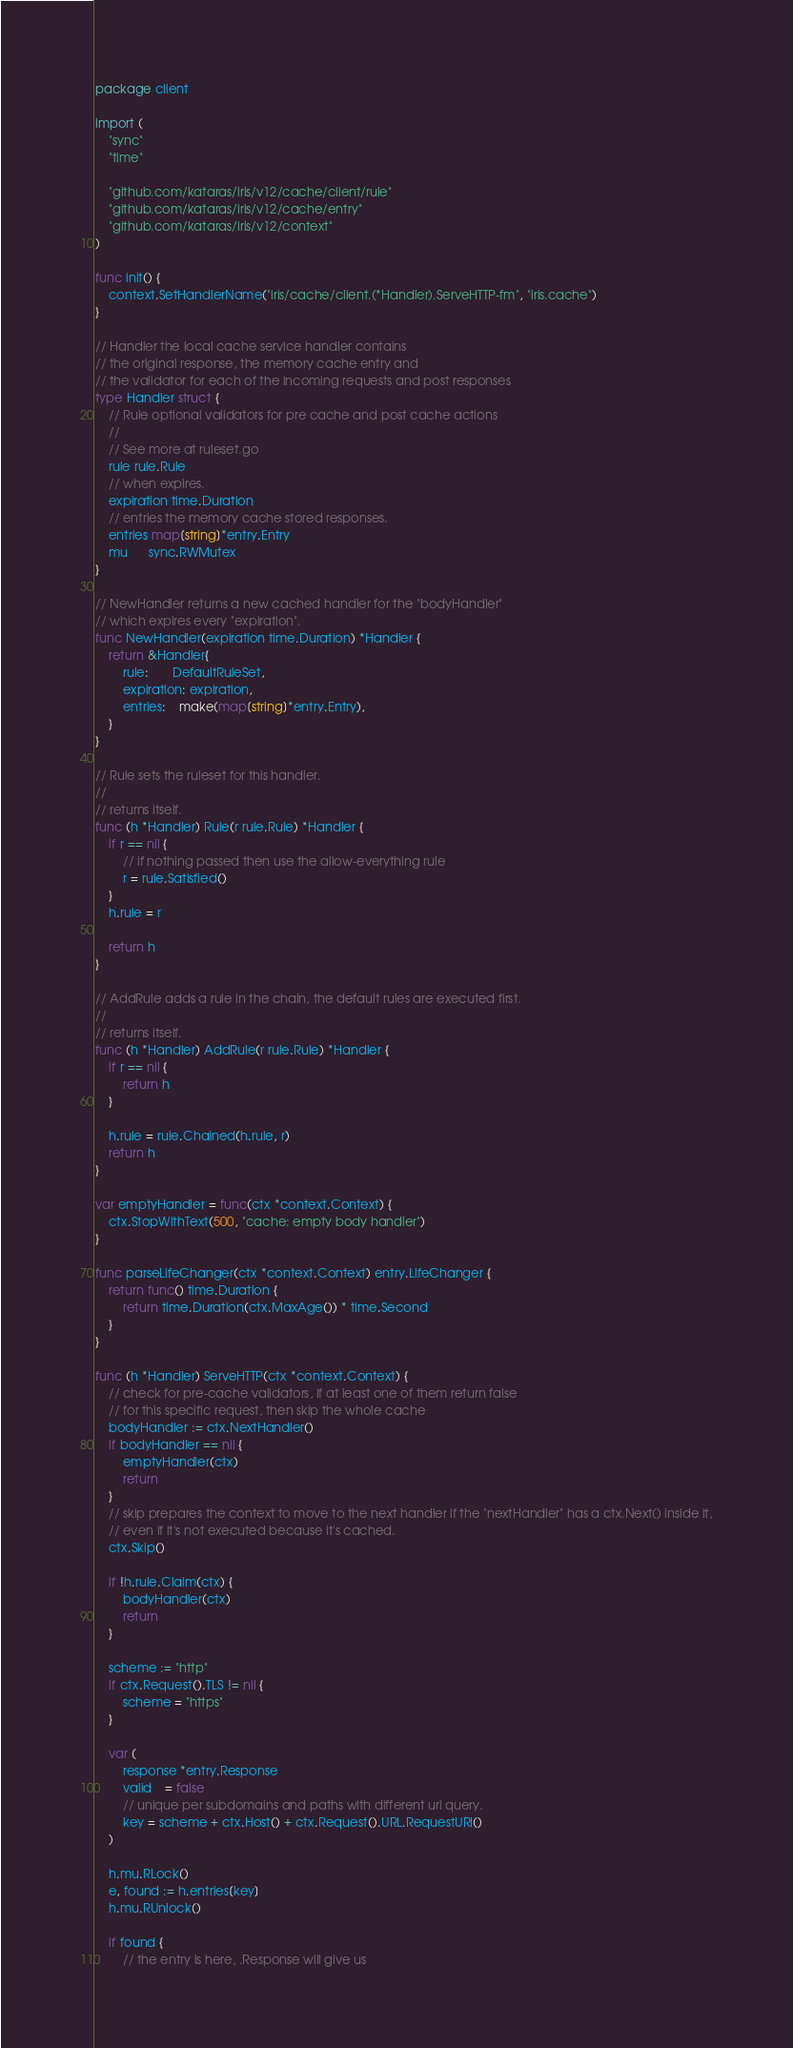Convert code to text. <code><loc_0><loc_0><loc_500><loc_500><_Go_>package client

import (
	"sync"
	"time"

	"github.com/kataras/iris/v12/cache/client/rule"
	"github.com/kataras/iris/v12/cache/entry"
	"github.com/kataras/iris/v12/context"
)

func init() {
	context.SetHandlerName("iris/cache/client.(*Handler).ServeHTTP-fm", "iris.cache")
}

// Handler the local cache service handler contains
// the original response, the memory cache entry and
// the validator for each of the incoming requests and post responses
type Handler struct {
	// Rule optional validators for pre cache and post cache actions
	//
	// See more at ruleset.go
	rule rule.Rule
	// when expires.
	expiration time.Duration
	// entries the memory cache stored responses.
	entries map[string]*entry.Entry
	mu      sync.RWMutex
}

// NewHandler returns a new cached handler for the "bodyHandler"
// which expires every "expiration".
func NewHandler(expiration time.Duration) *Handler {
	return &Handler{
		rule:       DefaultRuleSet,
		expiration: expiration,
		entries:    make(map[string]*entry.Entry),
	}
}

// Rule sets the ruleset for this handler.
//
// returns itself.
func (h *Handler) Rule(r rule.Rule) *Handler {
	if r == nil {
		// if nothing passed then use the allow-everything rule
		r = rule.Satisfied()
	}
	h.rule = r

	return h
}

// AddRule adds a rule in the chain, the default rules are executed first.
//
// returns itself.
func (h *Handler) AddRule(r rule.Rule) *Handler {
	if r == nil {
		return h
	}

	h.rule = rule.Chained(h.rule, r)
	return h
}

var emptyHandler = func(ctx *context.Context) {
	ctx.StopWithText(500, "cache: empty body handler")
}

func parseLifeChanger(ctx *context.Context) entry.LifeChanger {
	return func() time.Duration {
		return time.Duration(ctx.MaxAge()) * time.Second
	}
}

func (h *Handler) ServeHTTP(ctx *context.Context) {
	// check for pre-cache validators, if at least one of them return false
	// for this specific request, then skip the whole cache
	bodyHandler := ctx.NextHandler()
	if bodyHandler == nil {
		emptyHandler(ctx)
		return
	}
	// skip prepares the context to move to the next handler if the "nextHandler" has a ctx.Next() inside it,
	// even if it's not executed because it's cached.
	ctx.Skip()

	if !h.rule.Claim(ctx) {
		bodyHandler(ctx)
		return
	}

	scheme := "http"
	if ctx.Request().TLS != nil {
		scheme = "https"
	}

	var (
		response *entry.Response
		valid    = false
		// unique per subdomains and paths with different url query.
		key = scheme + ctx.Host() + ctx.Request().URL.RequestURI()
	)

	h.mu.RLock()
	e, found := h.entries[key]
	h.mu.RUnlock()

	if found {
		// the entry is here, .Response will give us</code> 